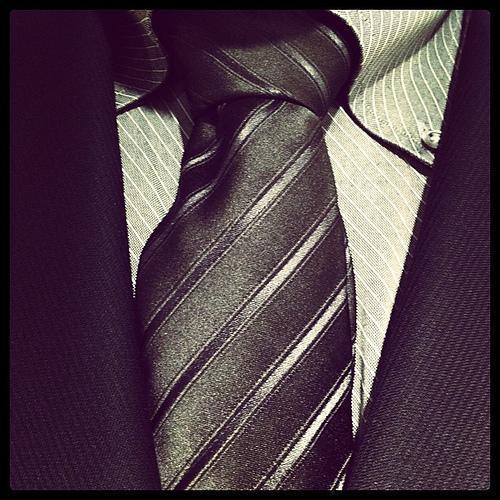How many ties the person wearing?
Give a very brief answer. 1. 